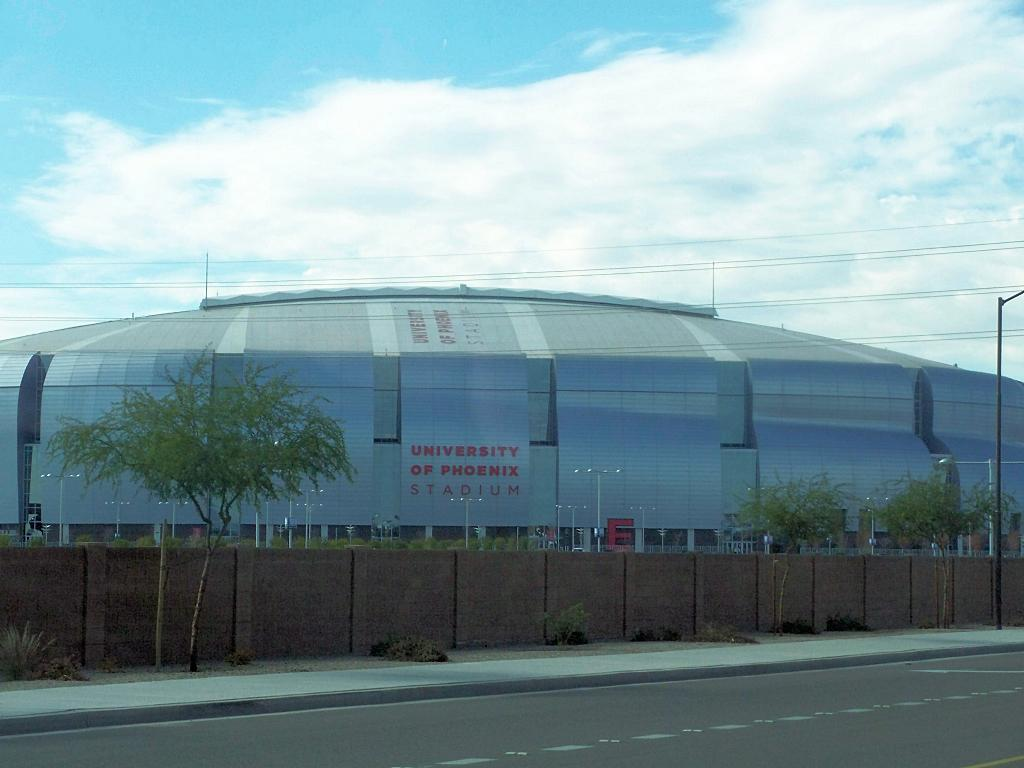What type of structure is visible in the image? There is a building in the image. What is located in front of the building? There are poles and a fence in front of the building. What other natural element can be seen in the image? There is a tree in the image. What is visible at the top of the image? The sky is visible at the top of the image. What else is present in the image that might be related to infrastructure? Power line cables are present in the image. What type of wind can be seen blowing through the building in the image? There is no wind visible in the image; it is a still image of a building with poles, a fence, a tree, and power line cables. What type of steel is used to construct the building in the image? The image does not provide information about the type of steel used in the construction of the building. 